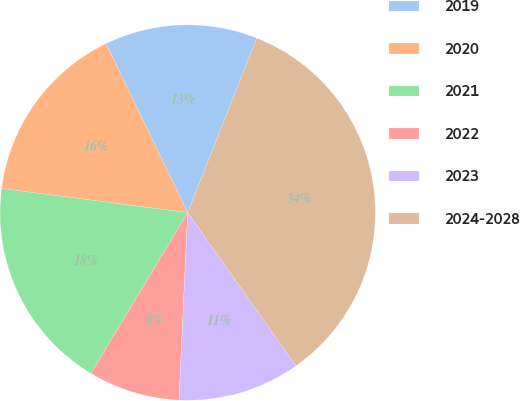<chart> <loc_0><loc_0><loc_500><loc_500><pie_chart><fcel>2019<fcel>2020<fcel>2021<fcel>2022<fcel>2023<fcel>2024-2028<nl><fcel>13.16%<fcel>15.79%<fcel>18.42%<fcel>7.89%<fcel>10.53%<fcel>34.21%<nl></chart> 